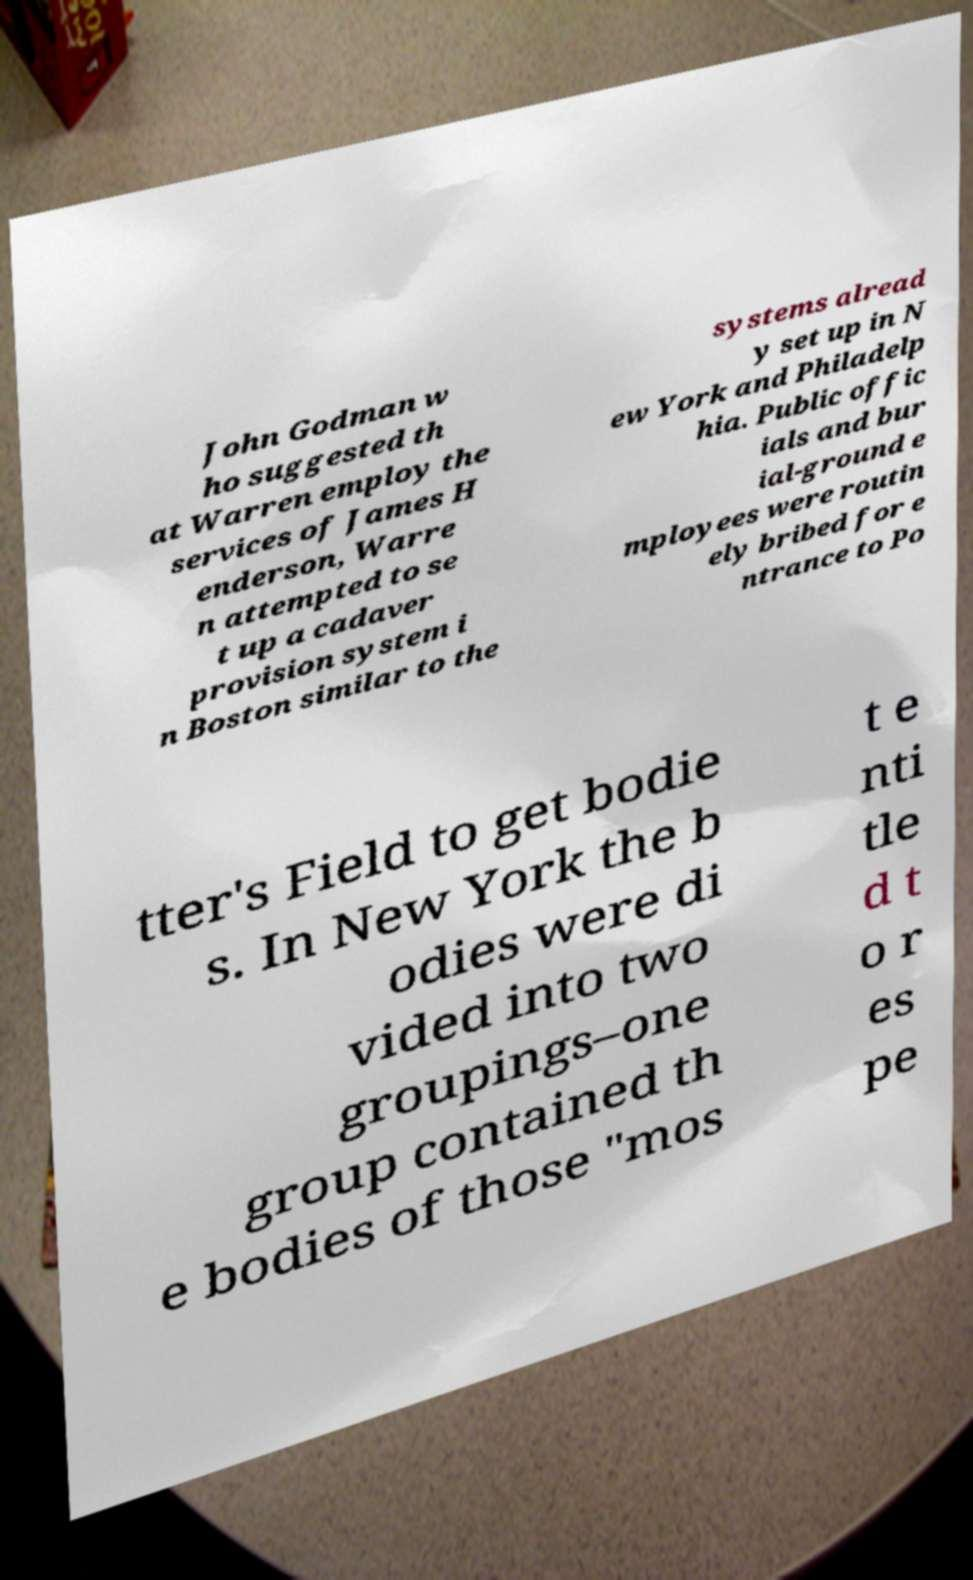Please identify and transcribe the text found in this image. John Godman w ho suggested th at Warren employ the services of James H enderson, Warre n attempted to se t up a cadaver provision system i n Boston similar to the systems alread y set up in N ew York and Philadelp hia. Public offic ials and bur ial-ground e mployees were routin ely bribed for e ntrance to Po tter's Field to get bodie s. In New York the b odies were di vided into two groupings–one group contained th e bodies of those "mos t e nti tle d t o r es pe 